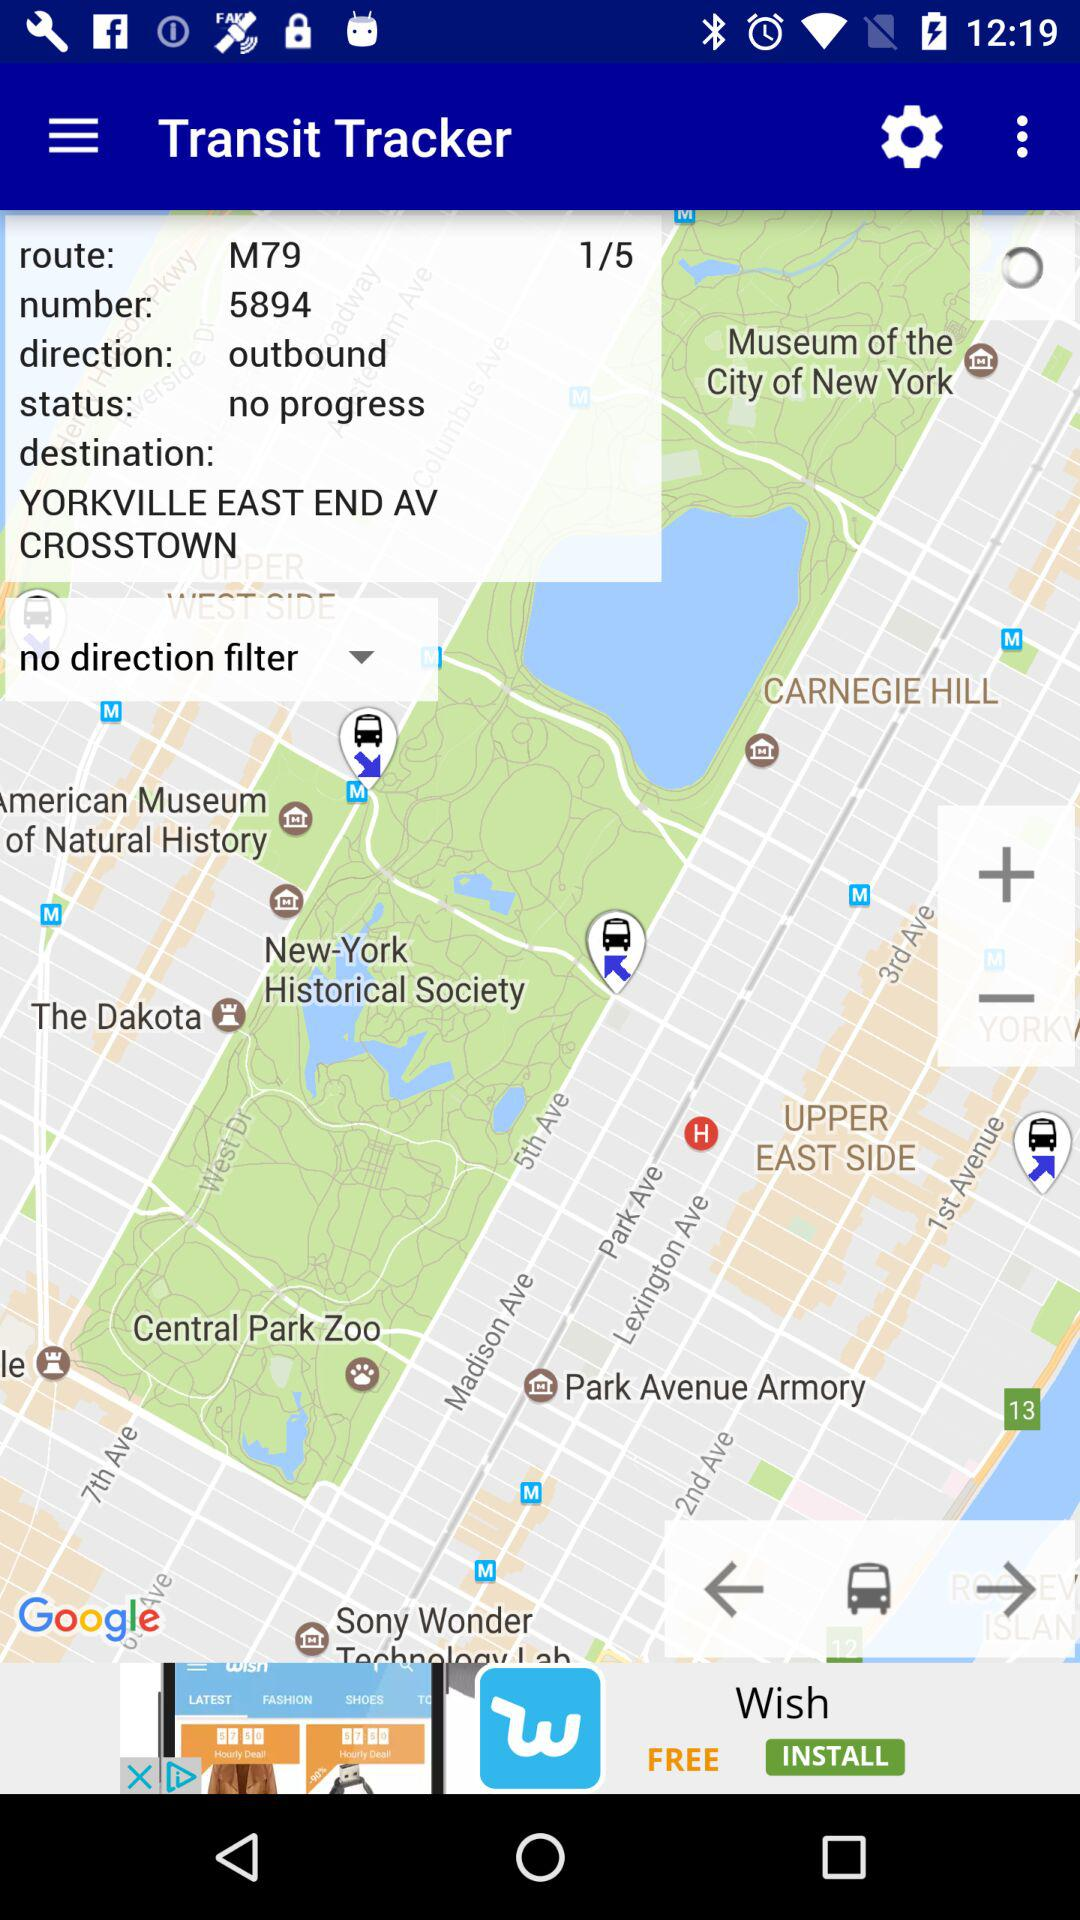What is the name of the application? The name of the application is "Transit Tracker". 